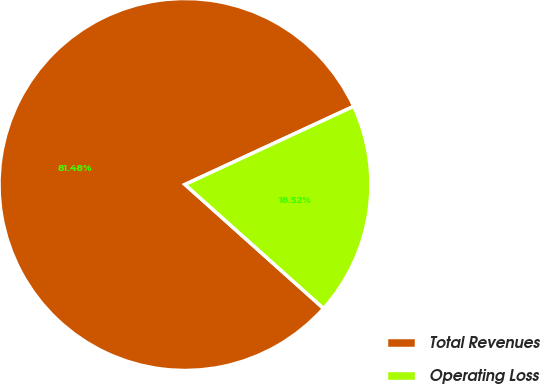Convert chart to OTSL. <chart><loc_0><loc_0><loc_500><loc_500><pie_chart><fcel>Total Revenues<fcel>Operating Loss<nl><fcel>81.48%<fcel>18.52%<nl></chart> 